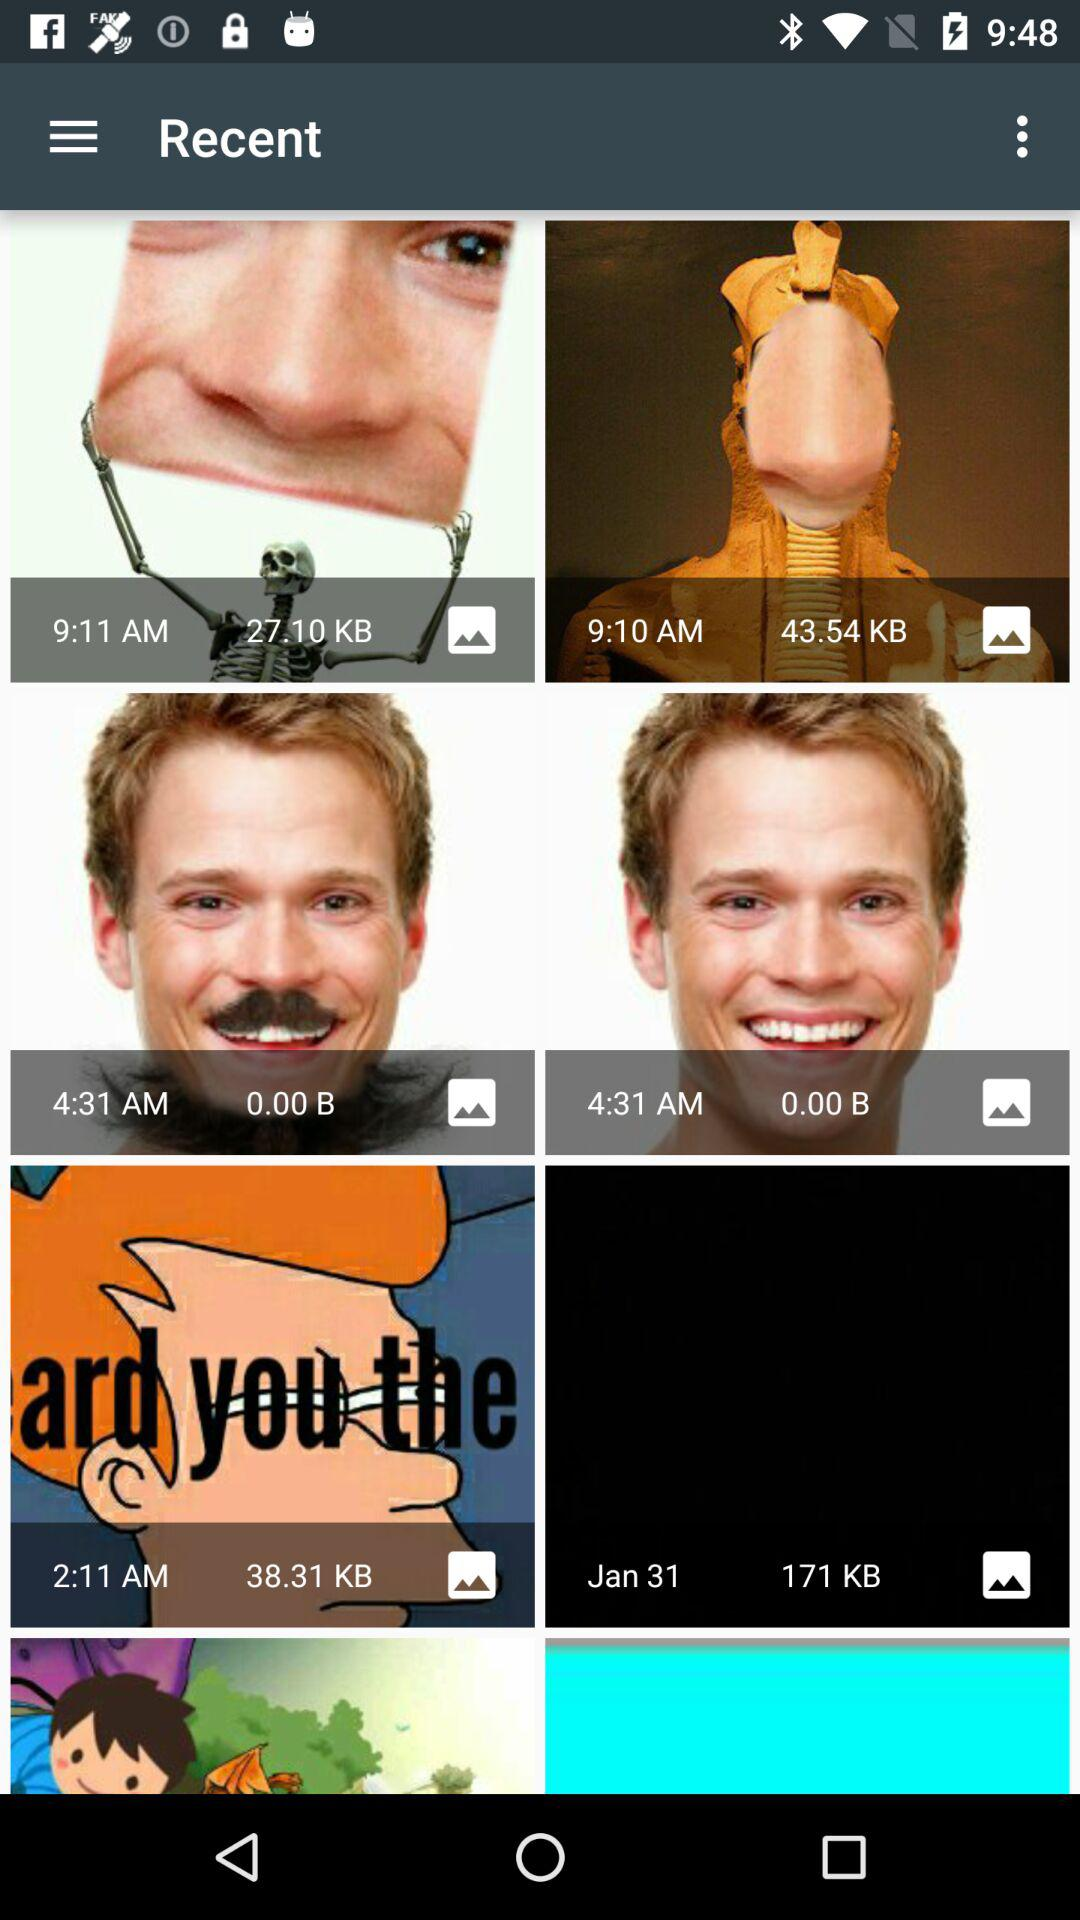What is the size of the file created at 9:11 AM in KB? The file created at 9:11 AM is 27.10 KB in size. 